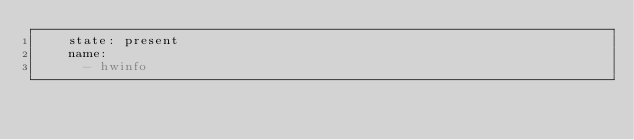<code> <loc_0><loc_0><loc_500><loc_500><_YAML_>    state: present
    name:
      - hwinfo
</code> 